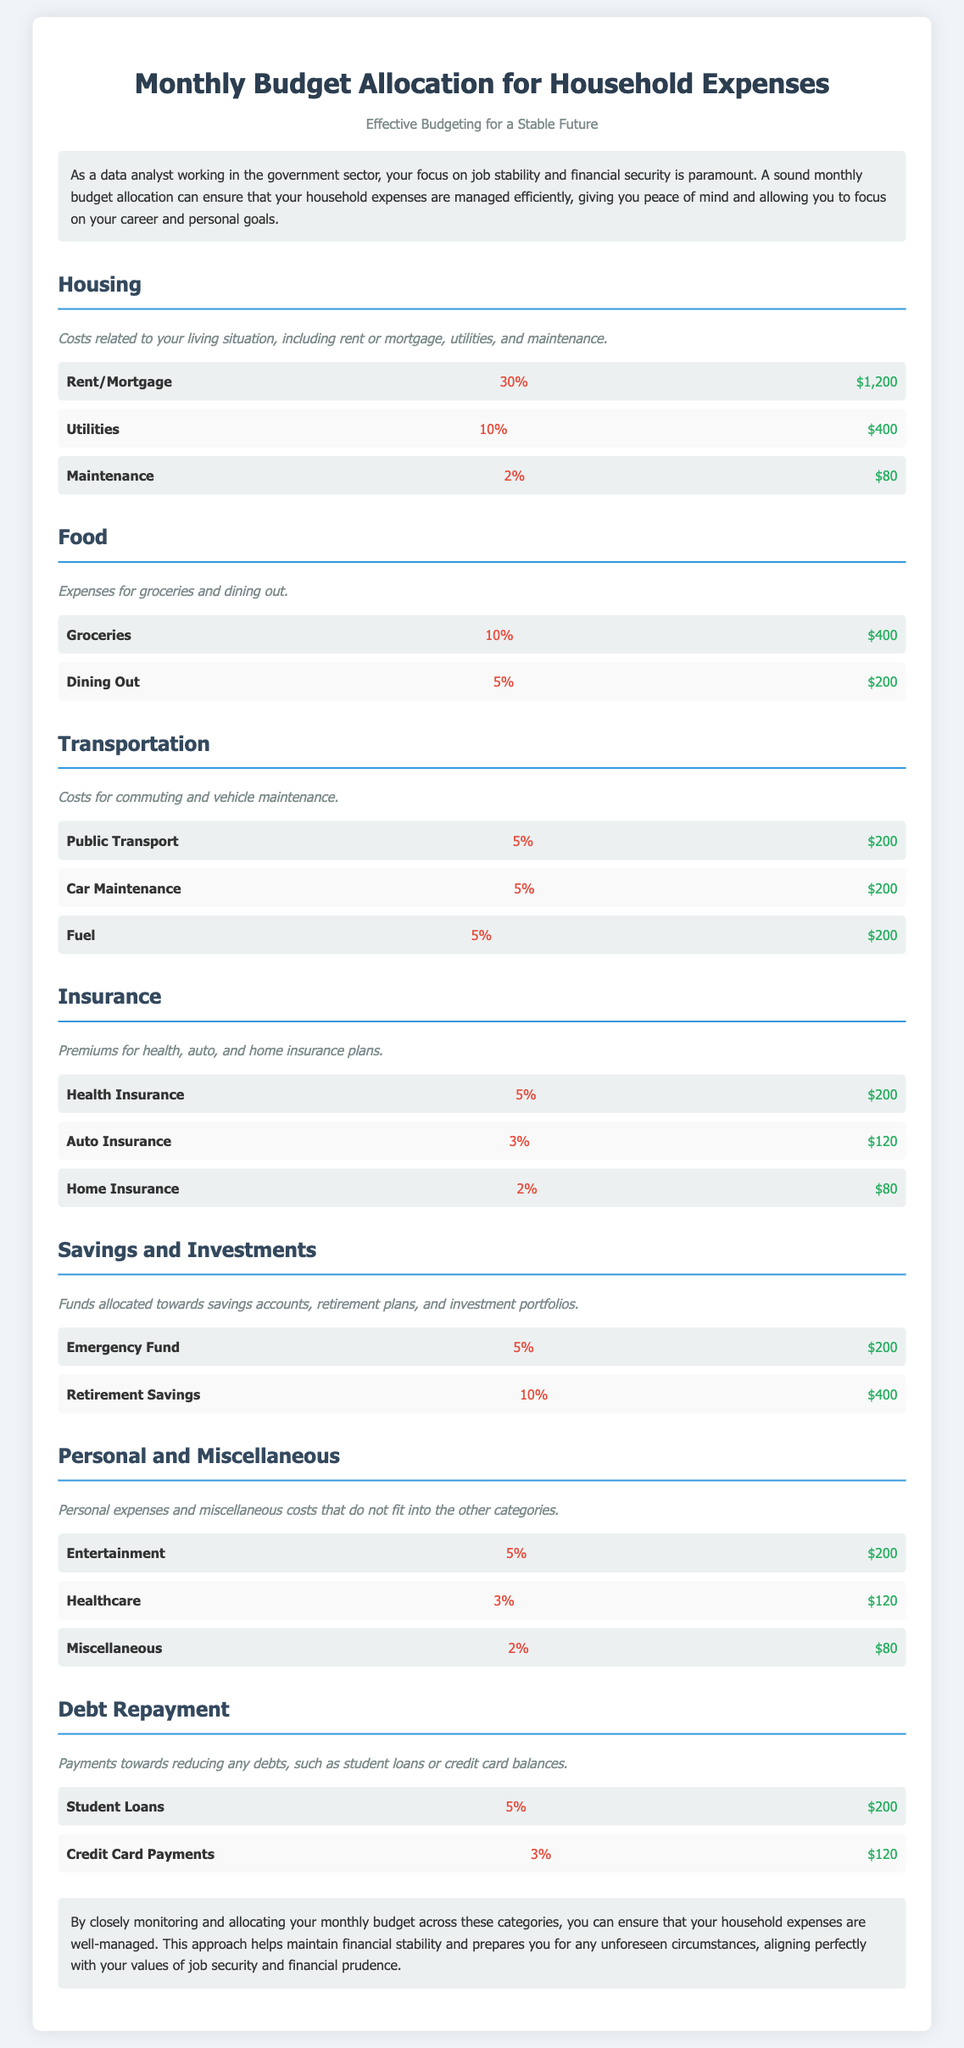What is the total percentage allocated to Housing? The total percentage for Housing is the sum of all its subcategories: 30% + 10% + 2% = 42%.
Answer: 42% What is the amount allocated for Dining Out? Dining Out is listed as a subcategory under Food with an allocation of $200.
Answer: $200 How much is allocated to the Emergency Fund? The Emergency Fund is listed under Savings and Investments, and it has an allocation of $200.
Answer: $200 What percentage of the budget is dedicated to Transportation? Transportation includes three subcategories each contributing 5%, so the total is 5% + 5% + 5% = 15%.
Answer: 15% Which category has the highest single expense allocation? The single highest expense is Rent/Mortgage, which is 30% of the budget.
Answer: Rent/Mortgage How much is allocated to Car Maintenance? Car Maintenance is a subcategory of Transportation and is allocated $200.
Answer: $200 What total amount is allocated to Health Insurance? Health Insurance is listed as 5% of the budget, which amounts to $200.
Answer: $200 Which category includes payments towards reducing debts? The category that includes payments towards reducing debts is Debt Repayment.
Answer: Debt Repayment What is the total amount allocated for Miscellaneous expenses? Miscellaneous is a subcategory listed with an allocation of $80, which is its total amount.
Answer: $80 